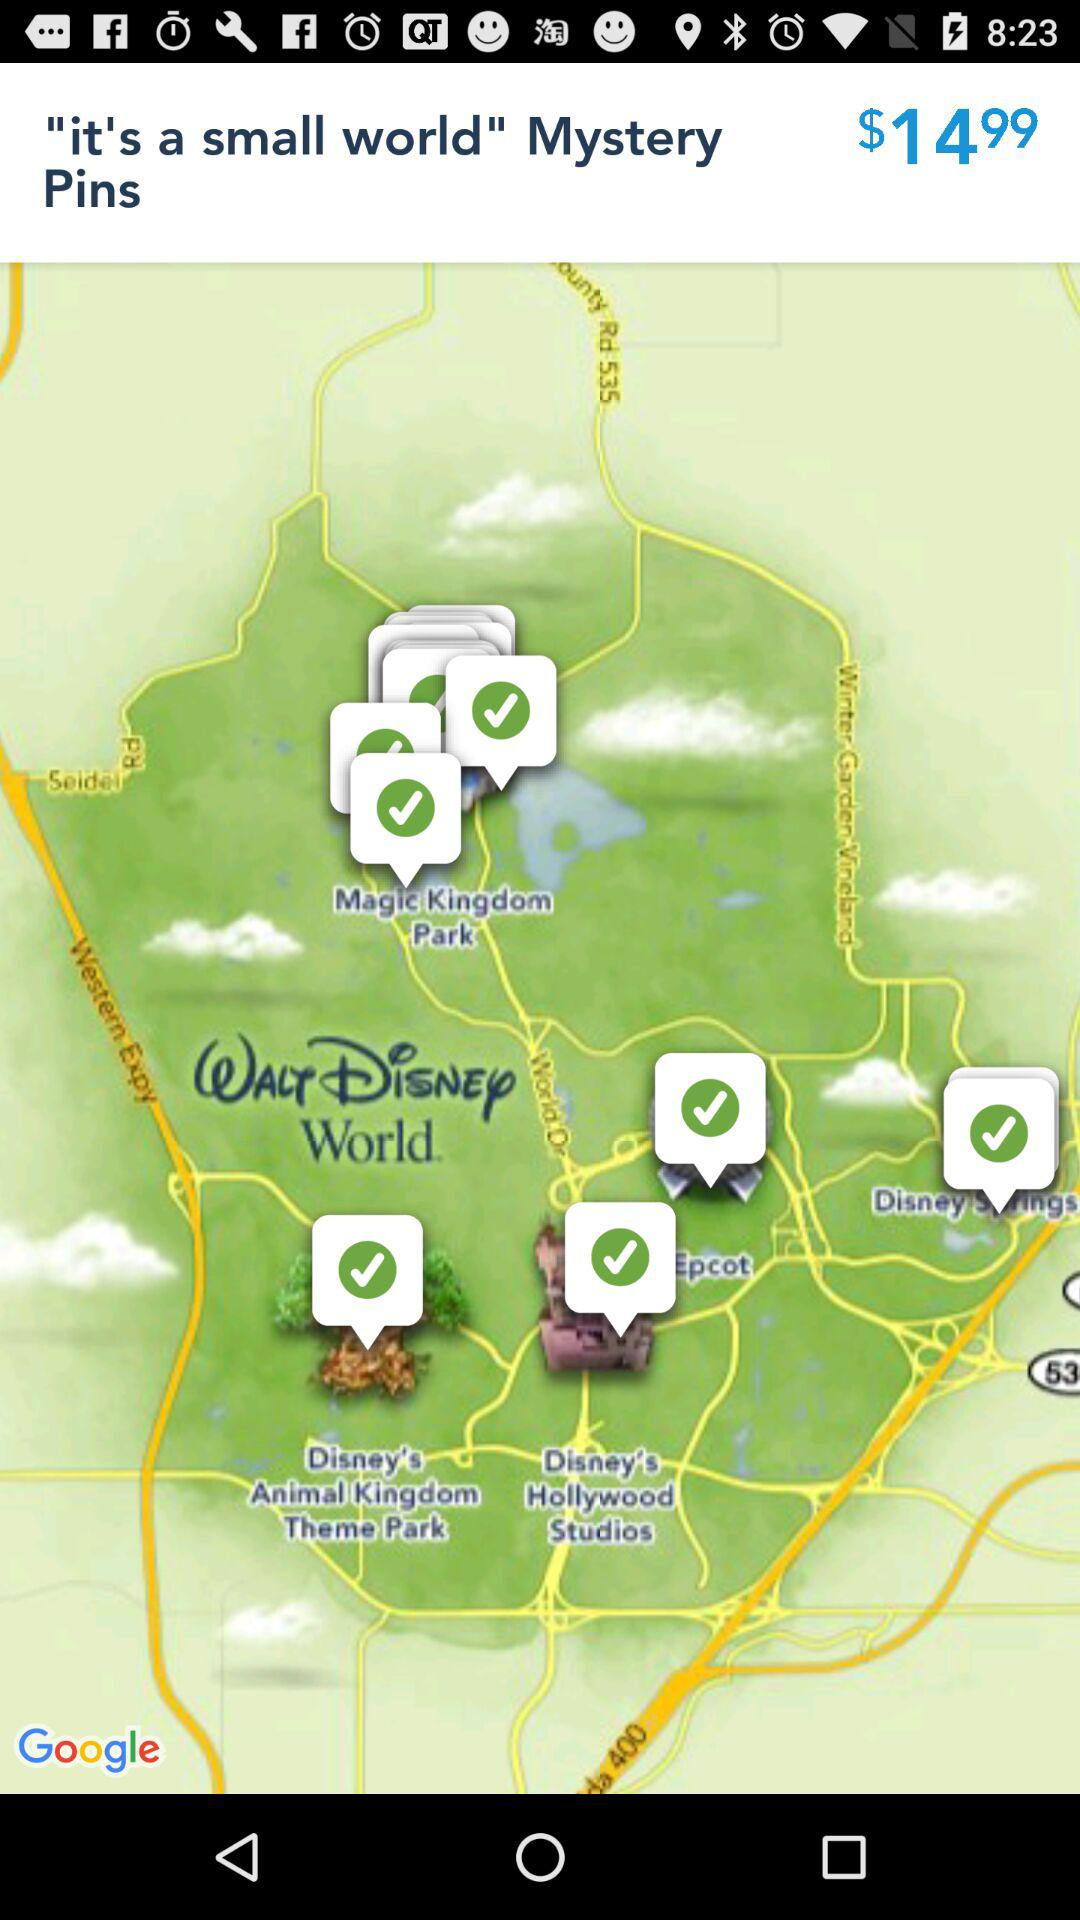What is the price of the "Mystery Pins"? The price is $14.99. 